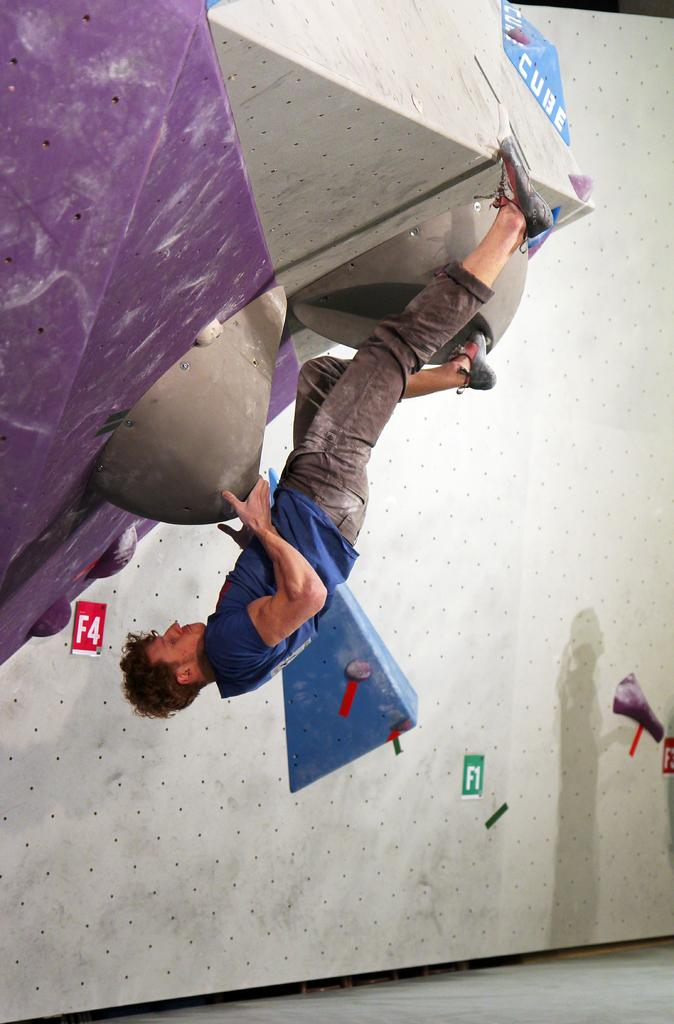Who is present in the image? There is a man in the image. What type of clothing is the man wearing? The man is wearing jeans and a blue t-shirt. What type of footwear is the man wearing? The man is wearing shoes. What else can be seen in the image besides the man? There are boards with words written on them in the image. What color is the orange in the image? There is no orange present in the image; it only features a man wearing jeans, a blue t-shirt, shoes, and boards with words written on them. 